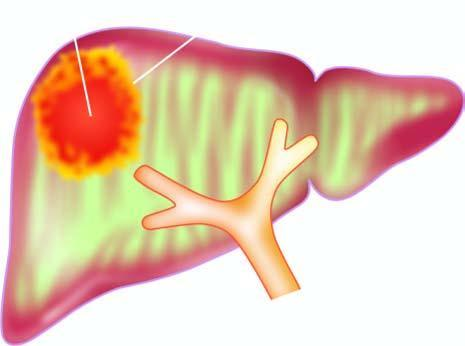s peripheral blood film showing marked neutrophilic leucocytosis commonly solitary?
Answer the question using a single word or phrase. No 